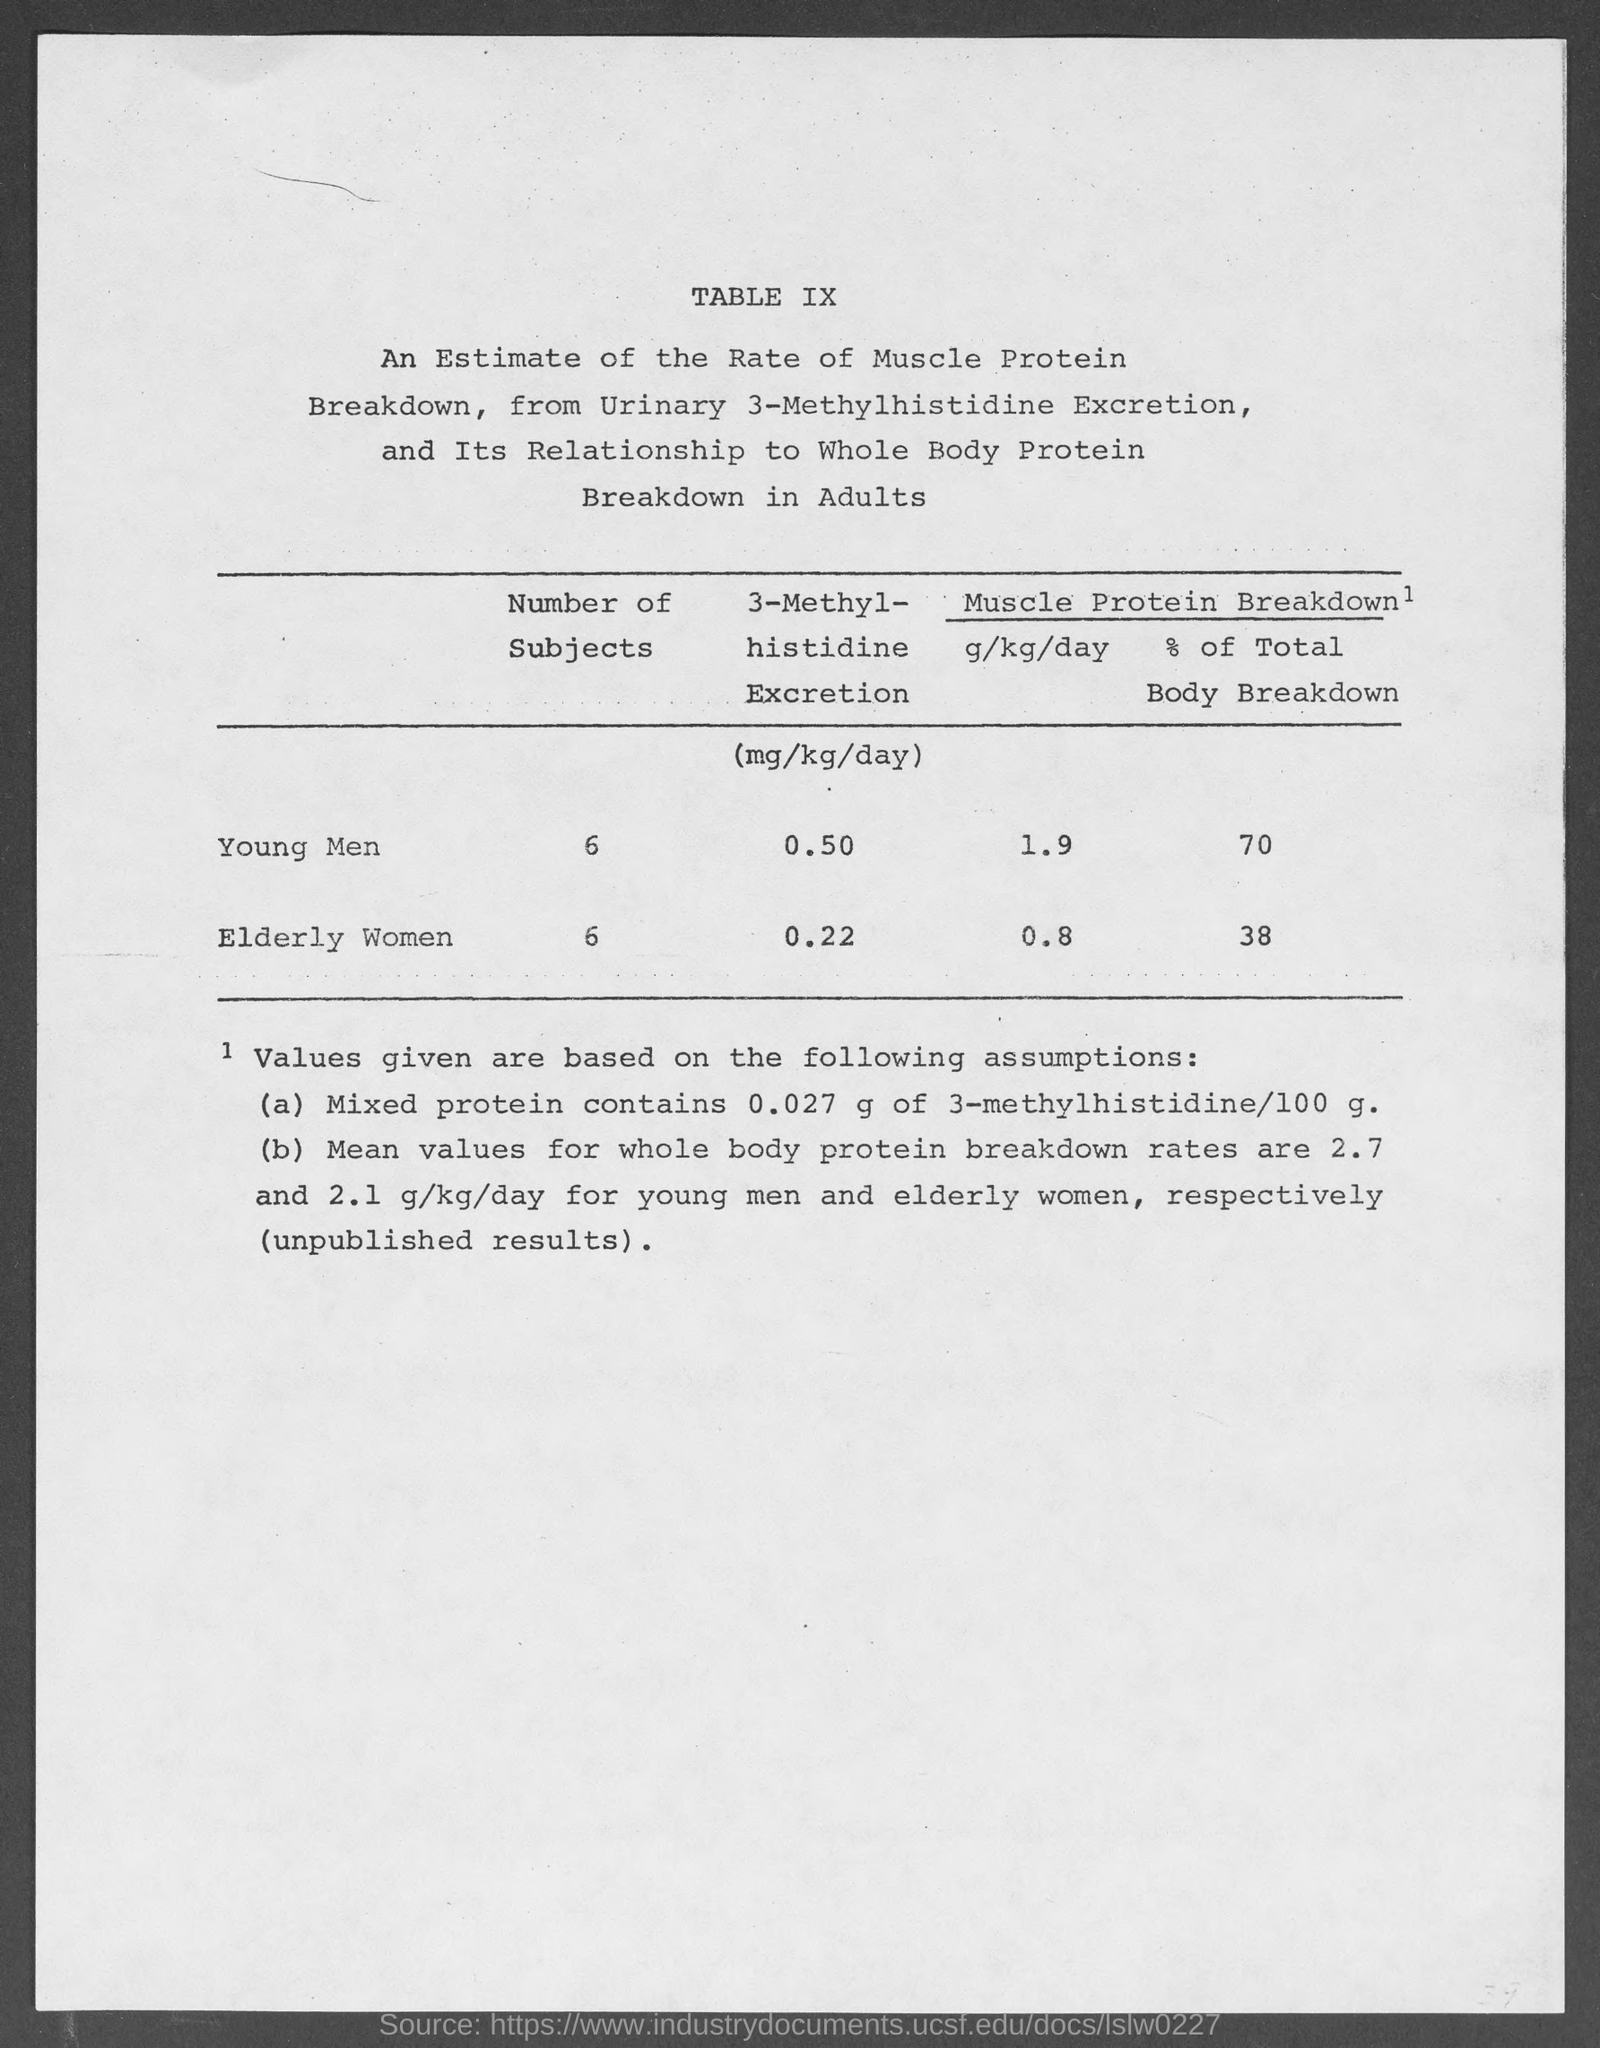What is the table no.?
Your answer should be compact. IX. What is the number of subjects in young men?
Give a very brief answer. 6. What is the number of subjects in elderly women ?
Your response must be concise. 6. What is the muscle protein breakdown g/kg/day in young men?
Give a very brief answer. 1.9. What is the muscle protein breakdown g/kg/day in elderly women ?
Provide a succinct answer. 0.8. What is the muscle protein breakdown % of total body breakdown in young men?
Keep it short and to the point. 70%. What is the muscle protein breakdown % of total body breakdown in elderly women?
Your answer should be very brief. 38. What is the 3-methyl-histidine excretion (mg/kg/day) in young men?
Your answer should be very brief. 0.50. What is the 3-methyl-histidine excretion (mg/kg/day) in elderly women ?
Your response must be concise. 0.22. 